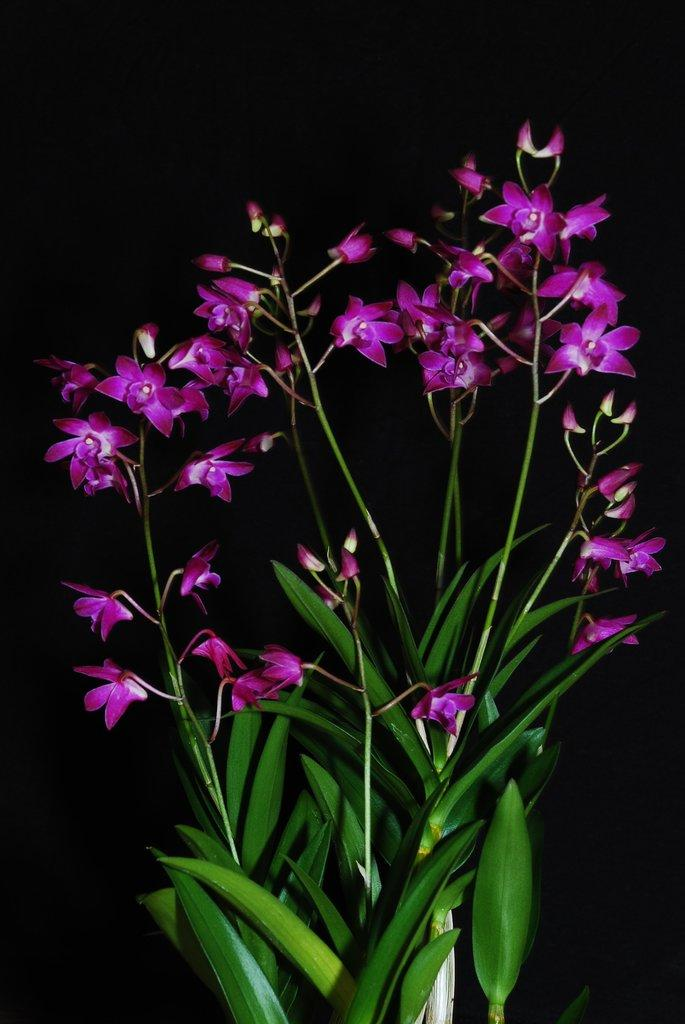What type of living organisms can be seen in the image? There are flowers and a plant visible in the image. Can you describe the plant in the image? Unfortunately, the facts provided do not give enough information to describe the plant in detail. Is there a ghost visible in the image? No, there is no ghost present in the image. What ideas are being discussed in the image? The image does not depict any ideas or discussions; it features flowers and a plant. 